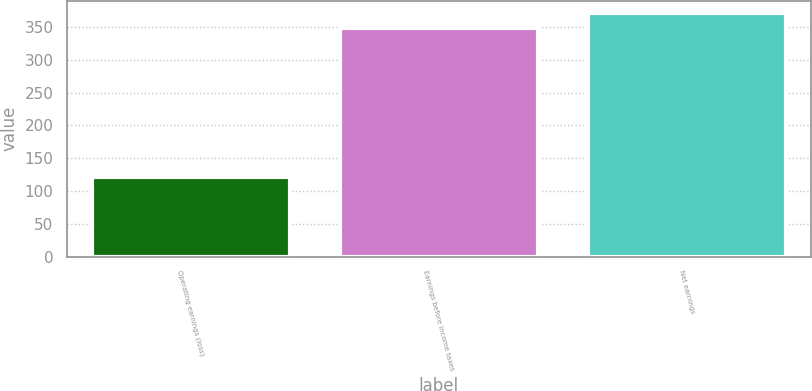<chart> <loc_0><loc_0><loc_500><loc_500><bar_chart><fcel>Operating earnings (loss)<fcel>Earnings before income taxes<fcel>Net earnings<nl><fcel>121.2<fcel>349.2<fcel>372<nl></chart> 